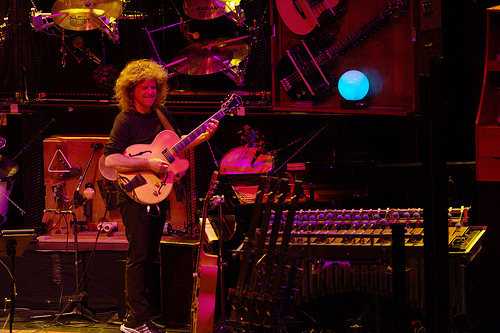<image>
Is there a guitar above the singer? No. The guitar is not positioned above the singer. The vertical arrangement shows a different relationship. 